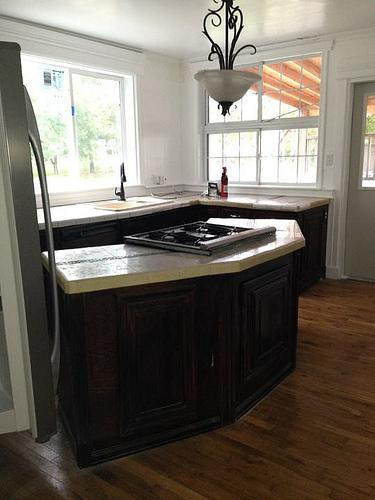Question: where is this shot?
Choices:
A. Bathroom.
B. Basement.
C. Living room.
D. Kitchen.
Answer with the letter. Answer: D Question: how many countertops are shown?
Choices:
A. 3.
B. 4.
C. 2.
D. 5.
Answer with the letter. Answer: C Question: what type of flooring?
Choices:
A. Tile.
B. Plastic.
C. Dirt.
D. Wood.
Answer with the letter. Answer: D Question: what is grey on the island?
Choices:
A. Knife.
B. Plate.
C. Counter.
D. Stove.
Answer with the letter. Answer: D Question: what are the countertops made of?
Choices:
A. Wood.
B. Granite.
C. Concrete.
D. Marble.
Answer with the letter. Answer: B 